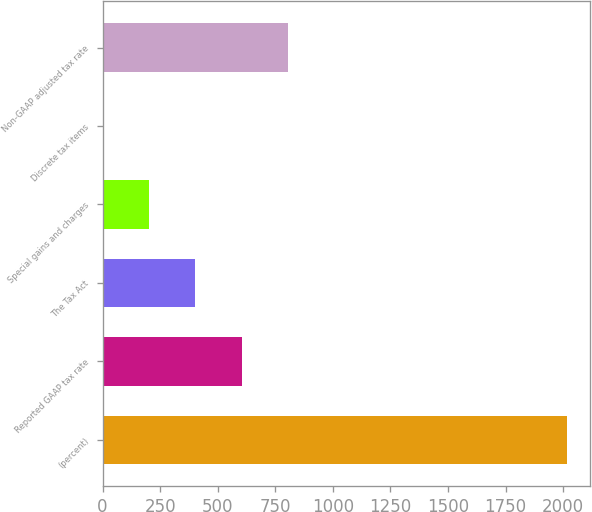Convert chart to OTSL. <chart><loc_0><loc_0><loc_500><loc_500><bar_chart><fcel>(percent)<fcel>Reported GAAP tax rate<fcel>The Tax Act<fcel>Special gains and charges<fcel>Discrete tax items<fcel>Non-GAAP adjusted tax rate<nl><fcel>2016<fcel>604.94<fcel>403.36<fcel>201.78<fcel>0.2<fcel>806.52<nl></chart> 